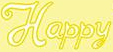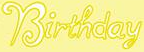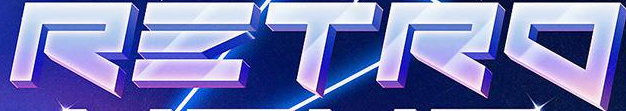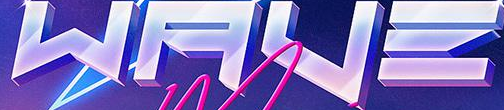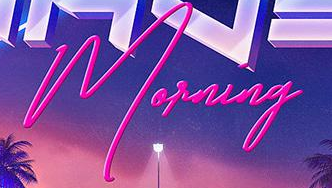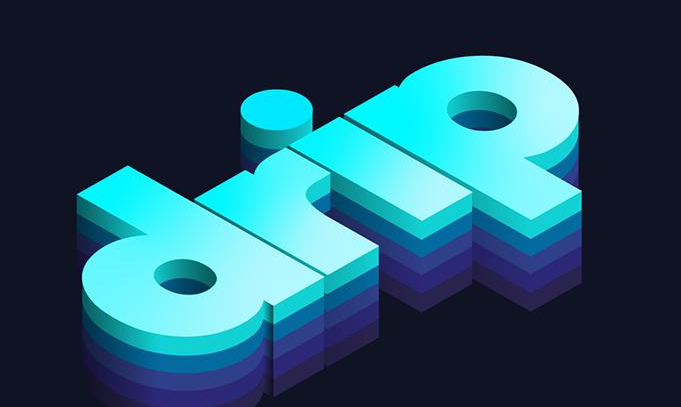What text appears in these images from left to right, separated by a semicolon? Happy; Birthday; RΞTRO; WAVΞ; Morning; drip 